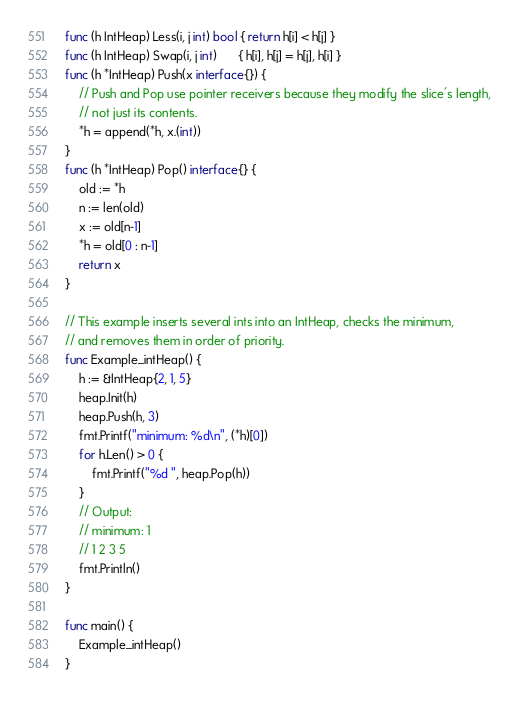Convert code to text. <code><loc_0><loc_0><loc_500><loc_500><_Go_>func (h IntHeap) Less(i, j int) bool { return h[i] < h[j] }
func (h IntHeap) Swap(i, j int)      { h[i], h[j] = h[j], h[i] }
func (h *IntHeap) Push(x interface{}) {
	// Push and Pop use pointer receivers because they modify the slice's length,
	// not just its contents.
	*h = append(*h, x.(int))
}
func (h *IntHeap) Pop() interface{} {
	old := *h
	n := len(old)
	x := old[n-1]
	*h = old[0 : n-1]
	return x
}

// This example inserts several ints into an IntHeap, checks the minimum,
// and removes them in order of priority.
func Example_intHeap() {
	h := &IntHeap{2, 1, 5}
	heap.Init(h)
	heap.Push(h, 3)
	fmt.Printf("minimum: %d\n", (*h)[0])
	for h.Len() > 0 {
		fmt.Printf("%d ", heap.Pop(h))
	}
	// Output:
	// minimum: 1
	// 1 2 3 5
	fmt.Println()
}

func main() {
	Example_intHeap()
}
</code> 